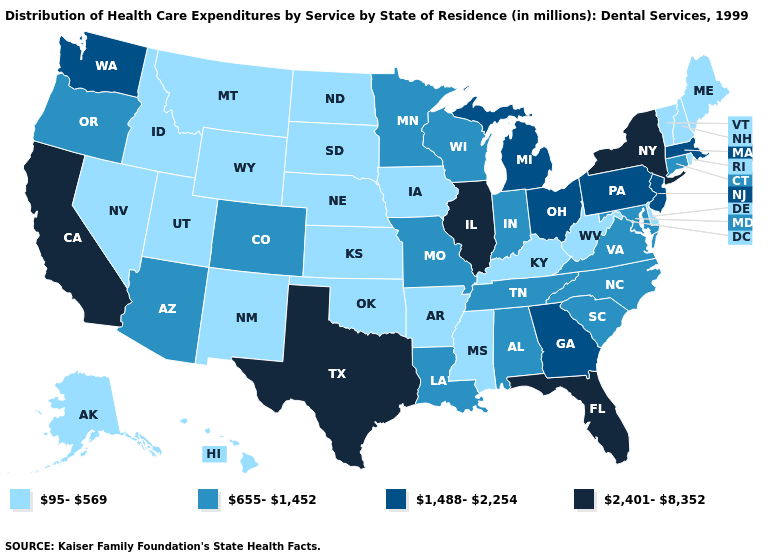What is the highest value in the USA?
Keep it brief. 2,401-8,352. Name the states that have a value in the range 655-1,452?
Quick response, please. Alabama, Arizona, Colorado, Connecticut, Indiana, Louisiana, Maryland, Minnesota, Missouri, North Carolina, Oregon, South Carolina, Tennessee, Virginia, Wisconsin. What is the highest value in states that border Ohio?
Keep it brief. 1,488-2,254. Name the states that have a value in the range 655-1,452?
Give a very brief answer. Alabama, Arizona, Colorado, Connecticut, Indiana, Louisiana, Maryland, Minnesota, Missouri, North Carolina, Oregon, South Carolina, Tennessee, Virginia, Wisconsin. Does South Carolina have the lowest value in the USA?
Answer briefly. No. Name the states that have a value in the range 2,401-8,352?
Quick response, please. California, Florida, Illinois, New York, Texas. Name the states that have a value in the range 655-1,452?
Keep it brief. Alabama, Arizona, Colorado, Connecticut, Indiana, Louisiana, Maryland, Minnesota, Missouri, North Carolina, Oregon, South Carolina, Tennessee, Virginia, Wisconsin. What is the lowest value in the West?
Short answer required. 95-569. Among the states that border North Carolina , which have the lowest value?
Be succinct. South Carolina, Tennessee, Virginia. Which states have the lowest value in the South?
Concise answer only. Arkansas, Delaware, Kentucky, Mississippi, Oklahoma, West Virginia. What is the value of Kansas?
Concise answer only. 95-569. Does Oklahoma have the lowest value in the USA?
Quick response, please. Yes. Does New Mexico have the highest value in the West?
Write a very short answer. No. Does Oklahoma have the lowest value in the USA?
Answer briefly. Yes. What is the value of Missouri?
Concise answer only. 655-1,452. 